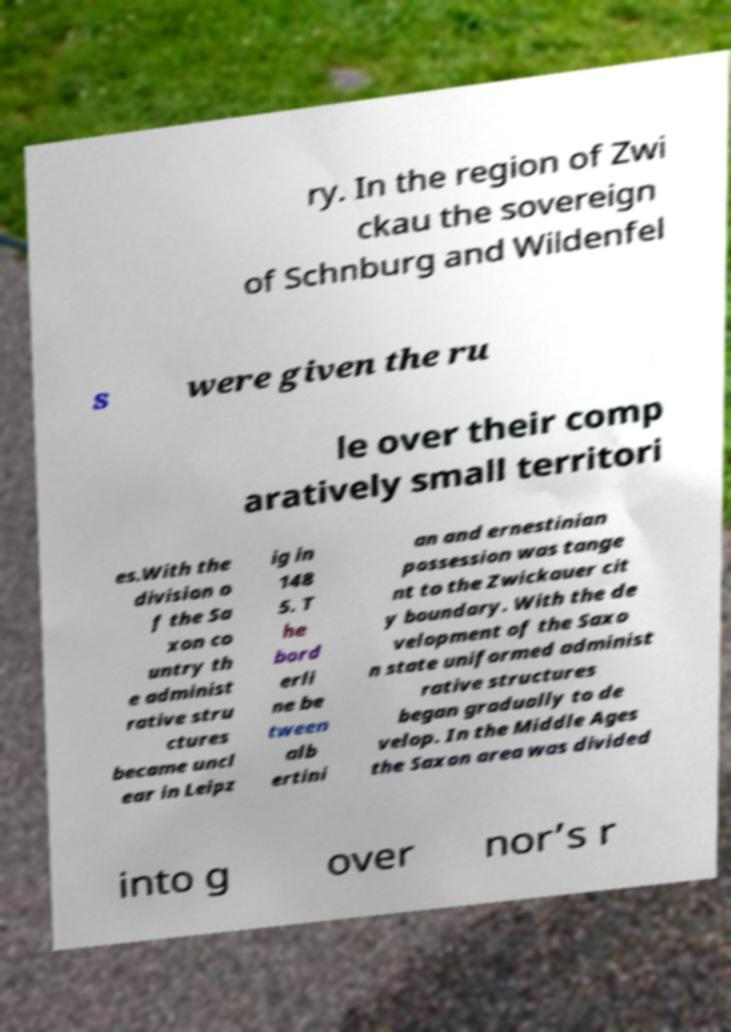For documentation purposes, I need the text within this image transcribed. Could you provide that? ry. In the region of Zwi ckau the sovereign of Schnburg and Wildenfel s were given the ru le over their comp aratively small territori es.With the division o f the Sa xon co untry th e administ rative stru ctures became uncl ear in Leipz ig in 148 5. T he bord erli ne be tween alb ertini an and ernestinian possession was tange nt to the Zwickauer cit y boundary. With the de velopment of the Saxo n state uniformed administ rative structures began gradually to de velop. In the Middle Ages the Saxon area was divided into g over nor’s r 